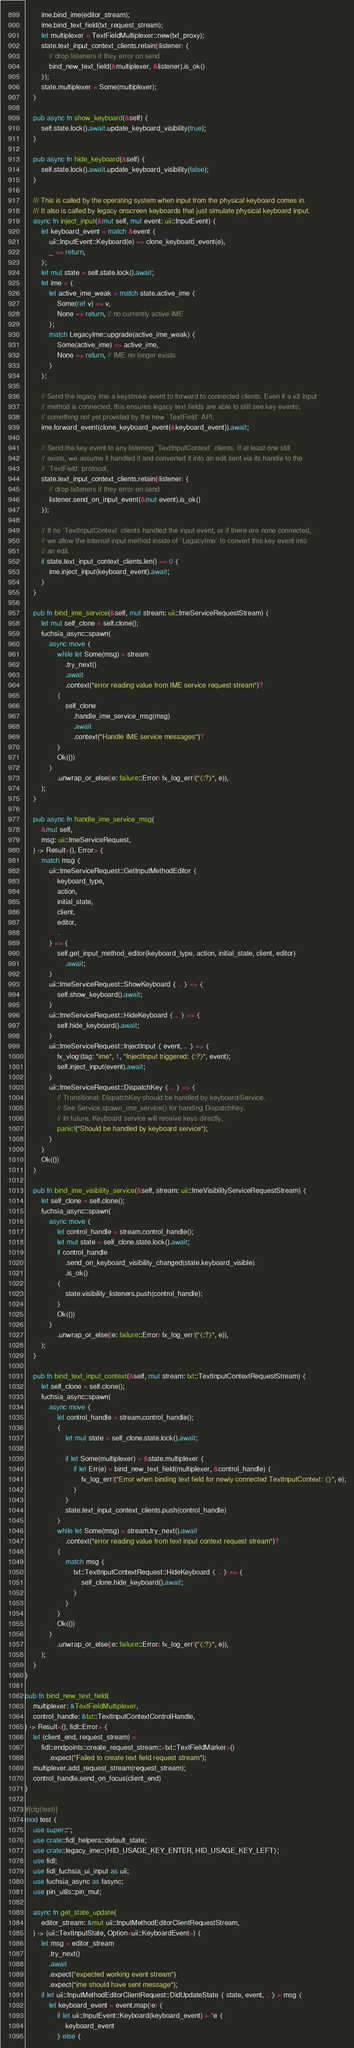<code> <loc_0><loc_0><loc_500><loc_500><_Rust_>        ime.bind_ime(editor_stream);
        ime.bind_text_field(txt_request_stream);
        let multiplexer = TextFieldMultiplexer::new(txt_proxy);
        state.text_input_context_clients.retain(|listener| {
            // drop listeners if they error on send
            bind_new_text_field(&multiplexer, &listener).is_ok()
        });
        state.multiplexer = Some(multiplexer);
    }

    pub async fn show_keyboard(&self) {
        self.state.lock().await.update_keyboard_visibility(true);
    }

    pub async fn hide_keyboard(&self) {
        self.state.lock().await.update_keyboard_visibility(false);
    }

    /// This is called by the operating system when input from the physical keyboard comes in.
    /// It also is called by legacy onscreen keyboards that just simulate physical keyboard input.
    async fn inject_input(&mut self, mut event: uii::InputEvent) {
        let keyboard_event = match &event {
            uii::InputEvent::Keyboard(e) => clone_keyboard_event(e),
            _ => return,
        };
        let mut state = self.state.lock().await;
        let ime = {
            let active_ime_weak = match state.active_ime {
                Some(ref v) => v,
                None => return, // no currently active IME
            };
            match LegacyIme::upgrade(active_ime_weak) {
                Some(active_ime) => active_ime,
                None => return, // IME no longer exists
            }
        };

        // Send the legacy ime a keystroke event to forward to connected clients. Even if a v2 input
        // method is connected, this ensures legacy text fields are able to still see key events;
        // something not yet provided by the new `TextField` API.
        ime.forward_event(clone_keyboard_event(&keyboard_event)).await;

        // Send the key event to any listening `TextInputContext` clients. If at least one still
        // exists, we assume it handled it and converted it into an edit sent via its handle to the
        // `TextField` protocol.
        state.text_input_context_clients.retain(|listener| {
            // drop listeners if they error on send
            listener.send_on_input_event(&mut event).is_ok()
        });

        // If no `TextInputContext` clients handled the input event, or if there are none connected,
        // we allow the internal input method inside of `LegacyIme` to convert this key event into
        // an edit.
        if state.text_input_context_clients.len() == 0 {
            ime.inject_input(keyboard_event).await;
        }
    }

    pub fn bind_ime_service(&self, mut stream: uii::ImeServiceRequestStream) {
        let mut self_clone = self.clone();
        fuchsia_async::spawn(
            async move {
                while let Some(msg) = stream
                    .try_next()
                    .await
                    .context("error reading value from IME service request stream")?
                {
                    self_clone
                        .handle_ime_service_msg(msg)
                        .await
                        .context("Handle IME service messages")?
                }
                Ok(())
            }
                .unwrap_or_else(|e: failure::Error| fx_log_err!("{:?}", e)),
        );
    }

    pub async fn handle_ime_service_msg(
        &mut self,
        msg: uii::ImeServiceRequest,
    ) -> Result<(), Error> {
        match msg {
            uii::ImeServiceRequest::GetInputMethodEditor {
                keyboard_type,
                action,
                initial_state,
                client,
                editor,
                ..
            } => {
                self.get_input_method_editor(keyboard_type, action, initial_state, client, editor)
                    .await;
            }
            uii::ImeServiceRequest::ShowKeyboard { .. } => {
                self.show_keyboard().await;
            }
            uii::ImeServiceRequest::HideKeyboard { .. } => {
                self.hide_keyboard().await;
            }
            uii::ImeServiceRequest::InjectInput { event, .. } => {
                fx_vlog!(tag: "ime", 1, "InjectInput triggered: {:?}", event);
                self.inject_input(event).await;
            }
            uii::ImeServiceRequest::DispatchKey { .. } => {
                // Transitional: DispatchKey should be handled by keyboard/Service.
                // See Service.spawn_ime_service() for handing DispatchKey.
                // In future, Keyboard service will receive keys directly.
                panic!("Should be handled by keyboard service");
            }
        }
        Ok(())
    }

    pub fn bind_ime_visibility_service(&self, stream: uii::ImeVisibilityServiceRequestStream) {
        let self_clone = self.clone();
        fuchsia_async::spawn(
            async move {
                let control_handle = stream.control_handle();
                let mut state = self_clone.state.lock().await;
                if control_handle
                    .send_on_keyboard_visibility_changed(state.keyboard_visible)
                    .is_ok()
                {
                    state.visibility_listeners.push(control_handle);
                }
                Ok(())
            }
                .unwrap_or_else(|e: failure::Error| fx_log_err!("{:?}", e)),
        );
    }

    pub fn bind_text_input_context(&self, mut stream: txt::TextInputContextRequestStream) {
        let self_clone = self.clone();
        fuchsia_async::spawn(
            async move {
                let control_handle = stream.control_handle();
                {
                    let mut state = self_clone.state.lock().await;

                    if let Some(multiplexer) = &state.multiplexer {
                        if let Err(e) = bind_new_text_field(multiplexer, &control_handle) {
                            fx_log_err!("Error when binding text field for newly connected TextInputContext: {}", e);
                        }
                    }
                    state.text_input_context_clients.push(control_handle)
                }
                while let Some(msg) = stream.try_next().await
                    .context("error reading value from text input context request stream")?
                {
                    match msg {
                        txt::TextInputContextRequest::HideKeyboard { .. } => {
                            self_clone.hide_keyboard().await;
                        }
                    }
                }
                Ok(())
            }
                .unwrap_or_else(|e: failure::Error| fx_log_err!("{:?}", e)),
        );
    }
}

pub fn bind_new_text_field(
    multiplexer: &TextFieldMultiplexer,
    control_handle: &txt::TextInputContextControlHandle,
) -> Result<(), fidl::Error> {
    let (client_end, request_stream) =
        fidl::endpoints::create_request_stream::<txt::TextFieldMarker>()
            .expect("Failed to create text field request stream");
    multiplexer.add_request_stream(request_stream);
    control_handle.send_on_focus(client_end)
}

#[cfg(test)]
mod test {
    use super::*;
    use crate::fidl_helpers::default_state;
    use crate::legacy_ime::{HID_USAGE_KEY_ENTER, HID_USAGE_KEY_LEFT};
    use fidl;
    use fidl_fuchsia_ui_input as uii;
    use fuchsia_async as fasync;
    use pin_utils::pin_mut;

    async fn get_state_update(
        editor_stream: &mut uii::InputMethodEditorClientRequestStream,
    ) -> (uii::TextInputState, Option<uii::KeyboardEvent>) {
        let msg = editor_stream
            .try_next()
            .await
            .expect("expected working event stream")
            .expect("ime should have sent message");
        if let uii::InputMethodEditorClientRequest::DidUpdateState { state, event, .. } = msg {
            let keyboard_event = event.map(|e| {
                if let uii::InputEvent::Keyboard(keyboard_event) = *e {
                    keyboard_event
                } else {</code> 